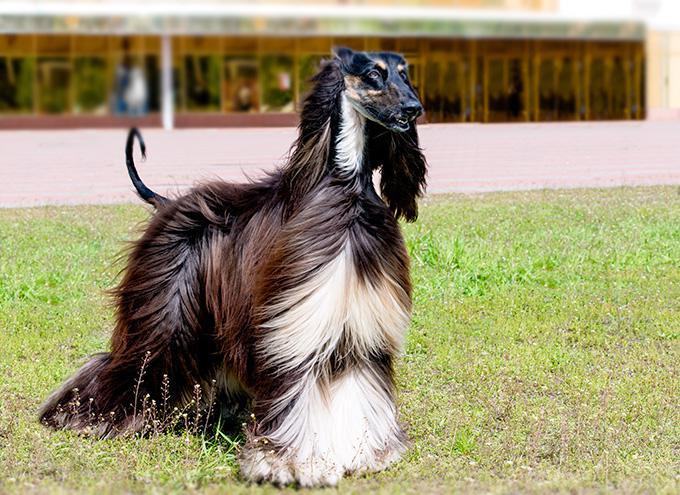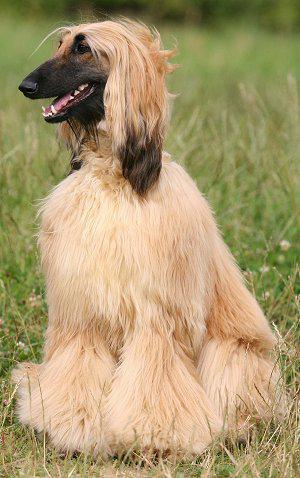The first image is the image on the left, the second image is the image on the right. Examine the images to the left and right. Is the description "In one of the images, there is at least one dog sitting down" accurate? Answer yes or no. Yes. The first image is the image on the left, the second image is the image on the right. Given the left and right images, does the statement "the dog on the right image is facing left." hold true? Answer yes or no. Yes. 